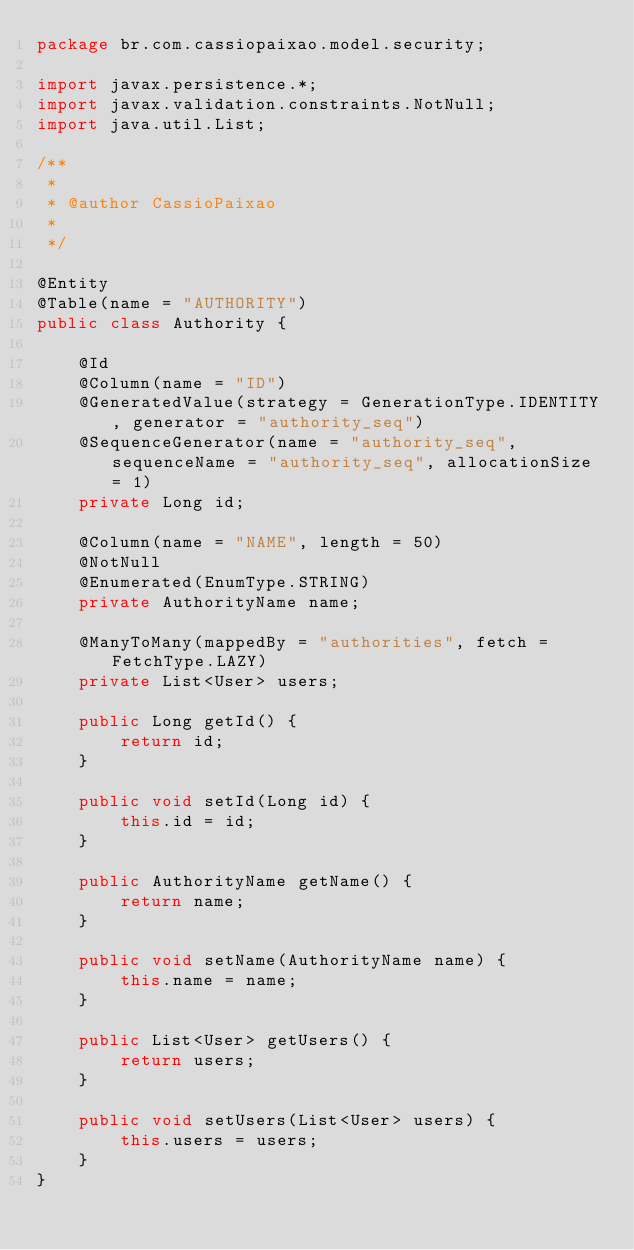Convert code to text. <code><loc_0><loc_0><loc_500><loc_500><_Java_>package br.com.cassiopaixao.model.security;

import javax.persistence.*;
import javax.validation.constraints.NotNull;
import java.util.List;

/**
 * 
 * @author CassioPaixao
 *
 */

@Entity
@Table(name = "AUTHORITY")
public class Authority {

    @Id
    @Column(name = "ID")
    @GeneratedValue(strategy = GenerationType.IDENTITY, generator = "authority_seq")
    @SequenceGenerator(name = "authority_seq", sequenceName = "authority_seq", allocationSize = 1)
    private Long id;

    @Column(name = "NAME", length = 50)
    @NotNull
    @Enumerated(EnumType.STRING)
    private AuthorityName name;

    @ManyToMany(mappedBy = "authorities", fetch = FetchType.LAZY)
    private List<User> users;

    public Long getId() {
        return id;
    }

    public void setId(Long id) {
        this.id = id;
    }

    public AuthorityName getName() {
        return name;
    }

    public void setName(AuthorityName name) {
        this.name = name;
    }

    public List<User> getUsers() {
        return users;
    }

    public void setUsers(List<User> users) {
        this.users = users;
    }
}</code> 